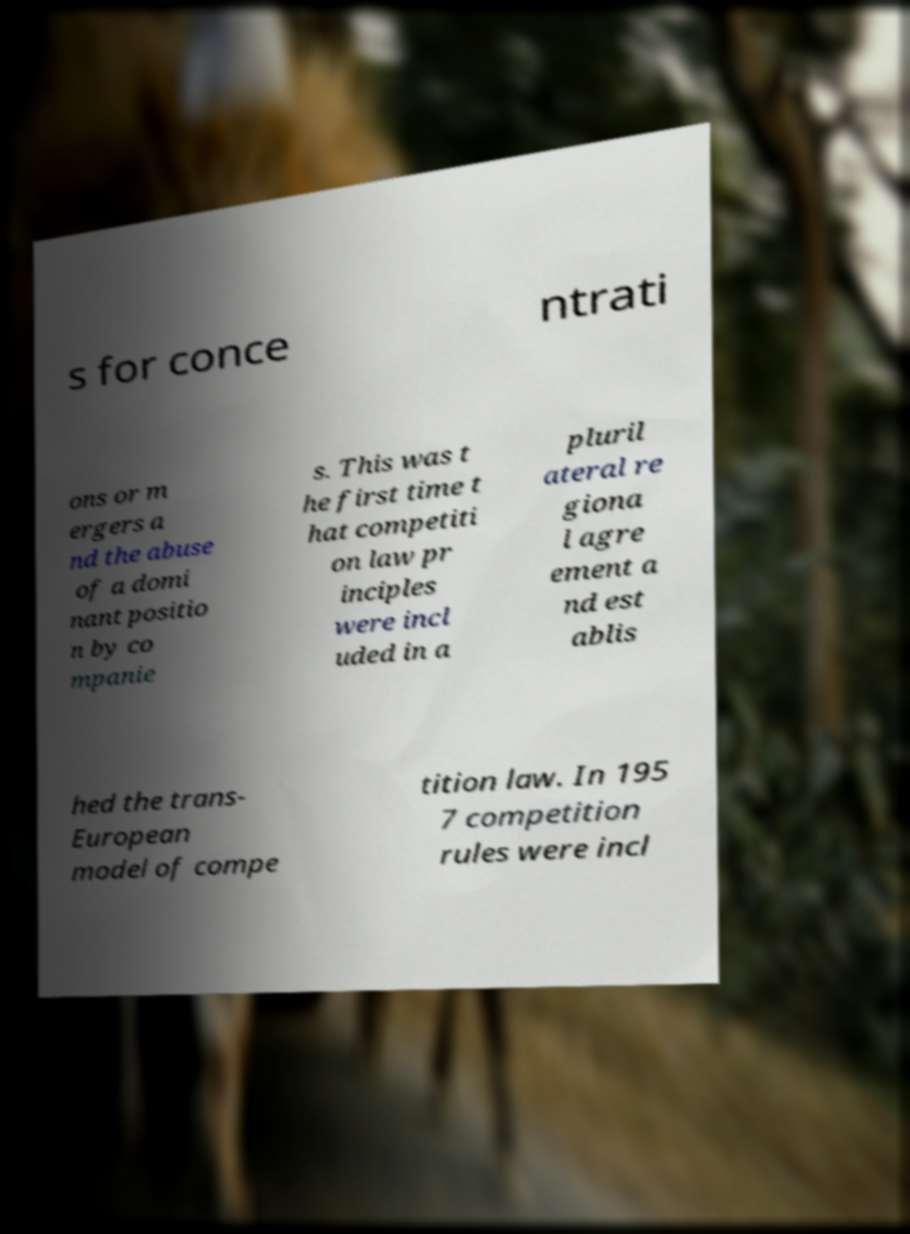Could you assist in decoding the text presented in this image and type it out clearly? s for conce ntrati ons or m ergers a nd the abuse of a domi nant positio n by co mpanie s. This was t he first time t hat competiti on law pr inciples were incl uded in a pluril ateral re giona l agre ement a nd est ablis hed the trans- European model of compe tition law. In 195 7 competition rules were incl 